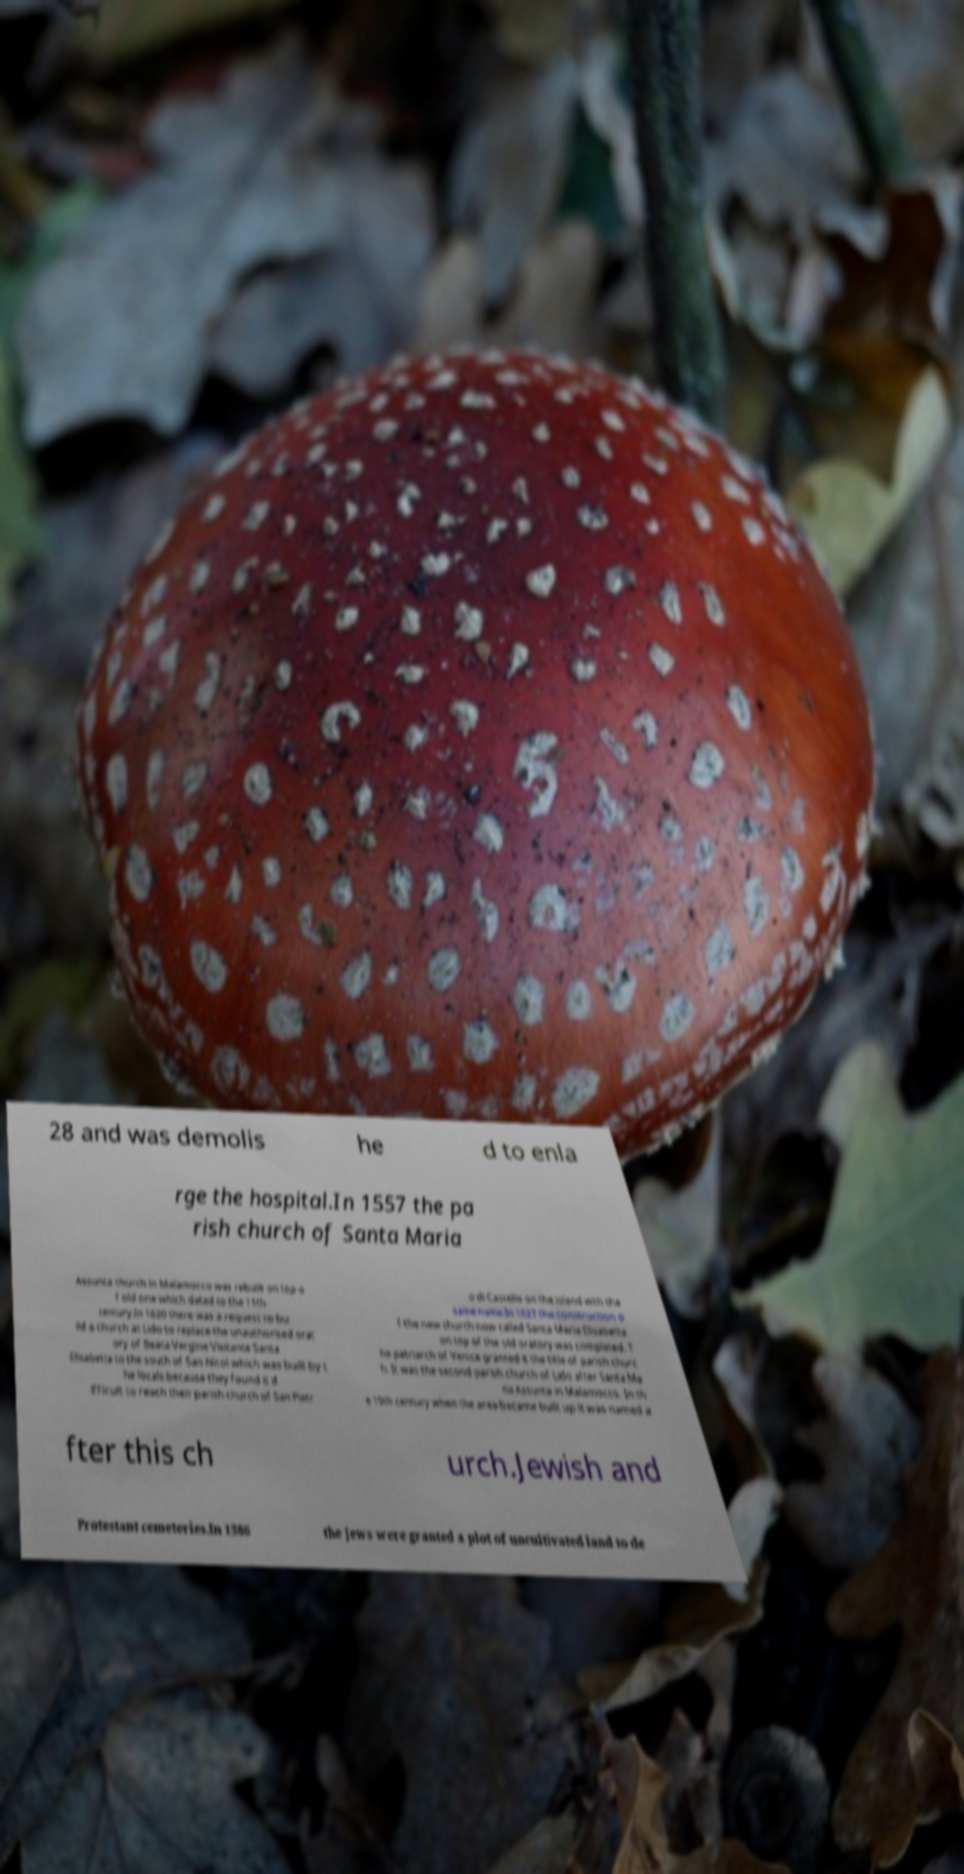Could you assist in decoding the text presented in this image and type it out clearly? 28 and was demolis he d to enla rge the hospital.In 1557 the pa rish church of Santa Maria Assunta church in Malamocco was rebuilt on top o f old one which dated to the 11th century.In 1620 there was a request to bu ild a church at Lido to replace the unauthorised orat ory of Beata Vergine Visitante Santa Elisabetta to the south of San Nicol which was built by t he locals because they found it d ifficult to reach their parish church of San Pietr o di Castello on the island with the same name.In 1627 the construction o f the new church now called Santa Maria Elisabetta on top of the old oratory was completed. T he patriarch of Venice granted it the title of parish churc h. It was the second parish church of Lido after Santa Ma ria Assunta in Malamocco. In th e 19th century when the area became built up it was named a fter this ch urch.Jewish and Protestant cemeteries.In 1386 the Jews were granted a plot of uncultivated land to de 